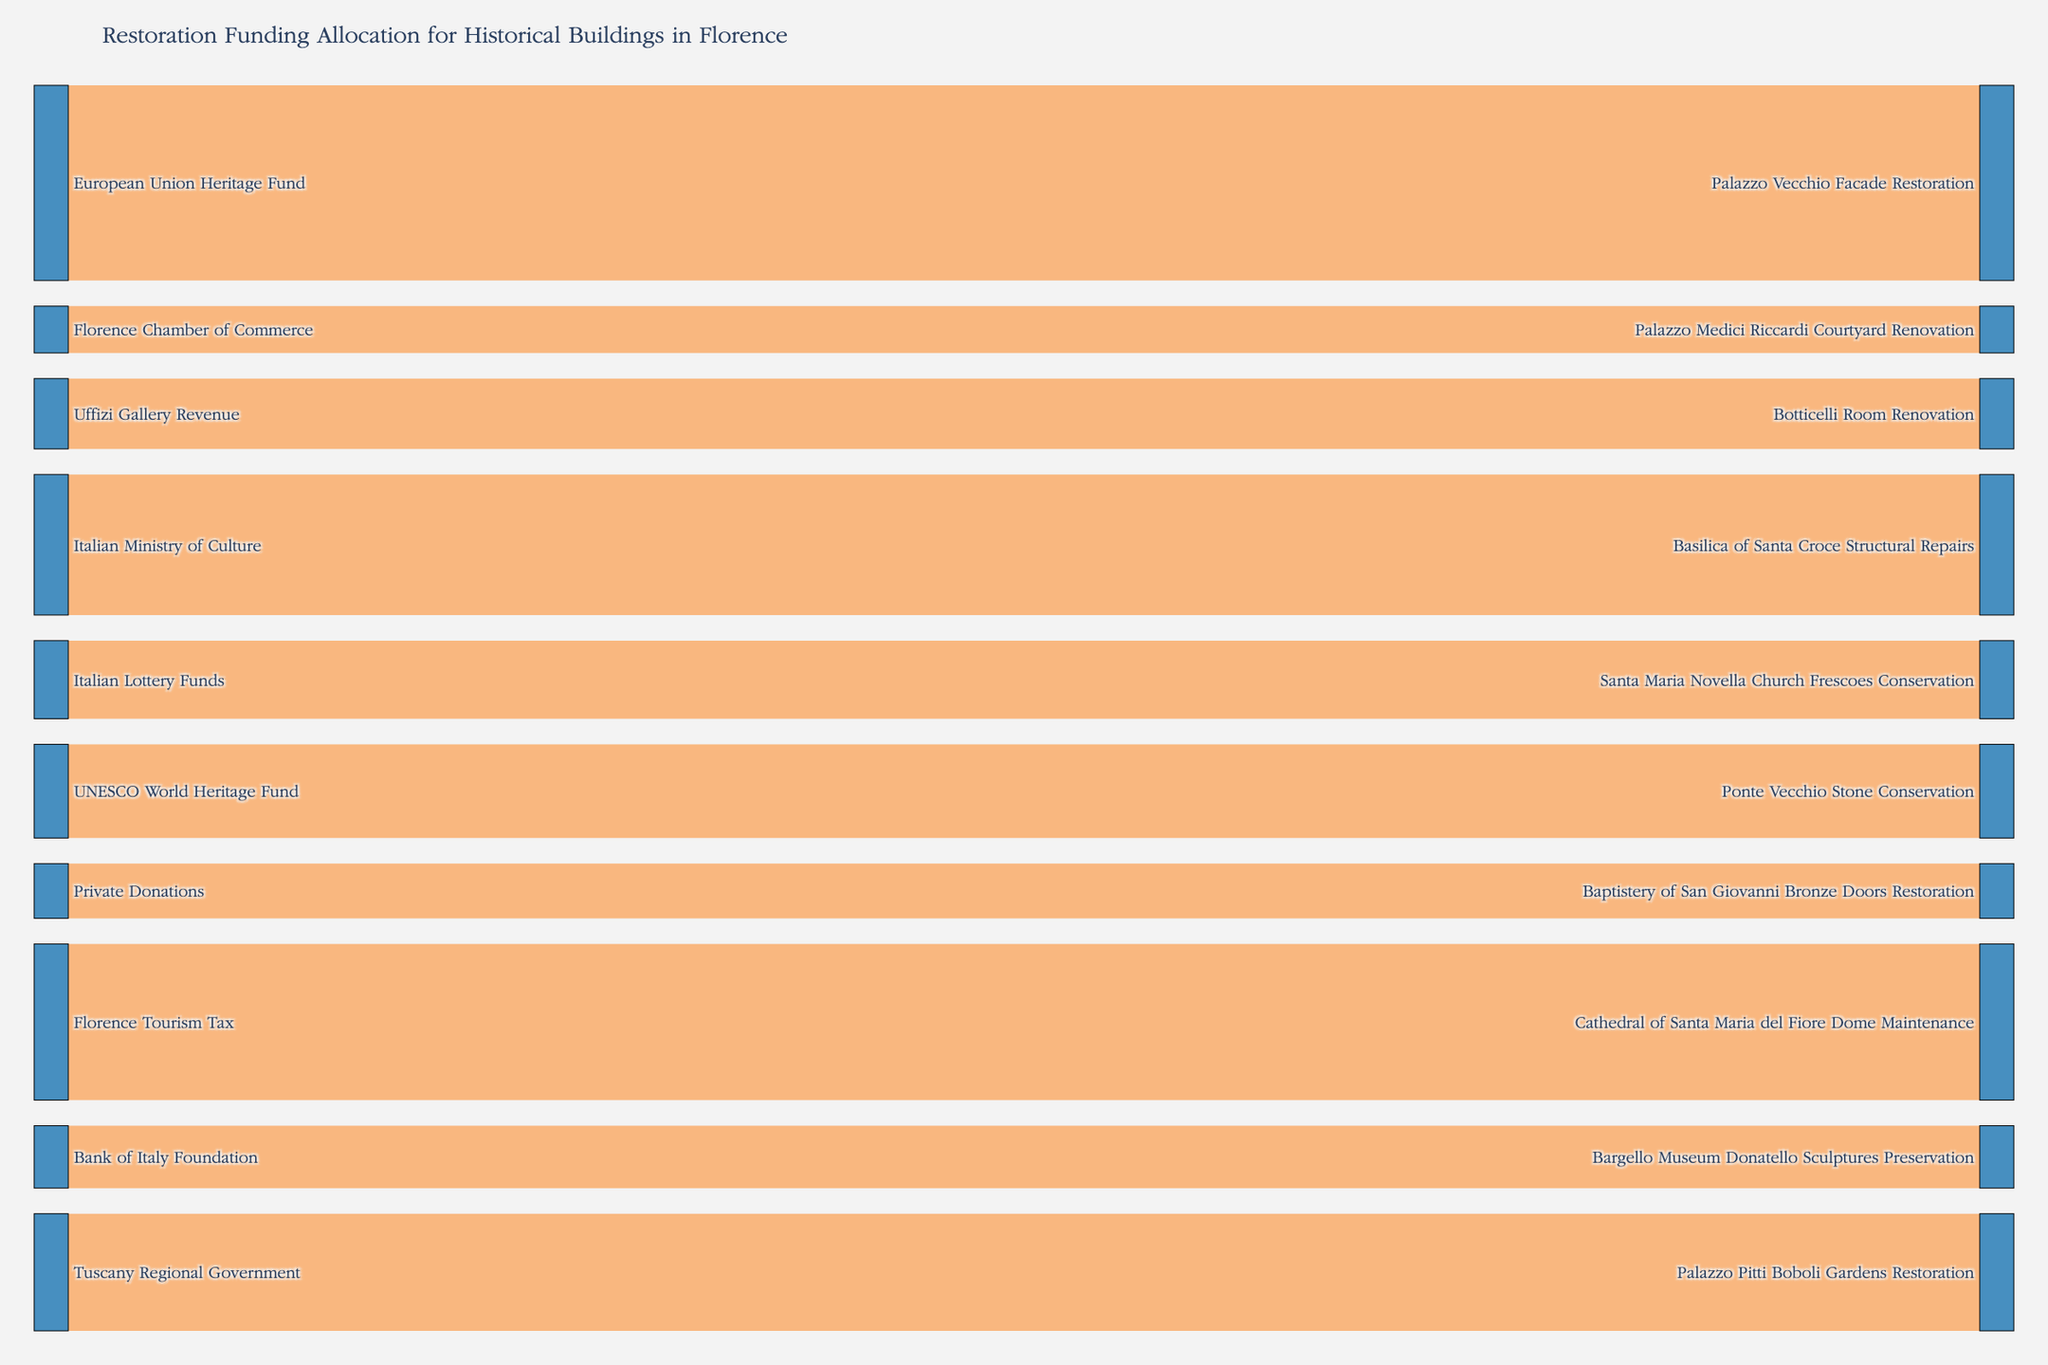What's the title of the figure? The title can be identified at the top of the Sankey diagram. It summarizes the primary focus of the visualization.
Answer: "Restoration Funding Allocation for Historical Buildings in Florence" How much funding was allocated to the Palazzo Vecchio Facade Restoration? Locate the destination "Palazzo Vecchio Facade Restoration" and follow the width of the flow from its source. The width directly correlates with the value.
Answer: 2,500,000 Which source contributed the highest amount of funding and to which projects? Compare the width of the flows from each source. The widest flow represents the highest value. Descriptions by the source name help identify the allocation projects.
Answer: "European Union Heritage Fund" contributed the highest, to "Palazzo Vecchio Facade Restoration" with 2,500,000 What is the total funding allocated for the Cathedral of Santa Maria del Fiore Dome Maintenance? Locate the destination "Cathedral of Santa Maria del Fiore Dome Maintenance" and sum the associated value flows leading to it.
Answer: 2,000,000 Which project received funding from the Friends of Florence Foundation? Trace the flow starting from "Friends of Florence Foundation" and see what destination it points towards.
Answer: Baptistery of San Giovanni Bronze Doors Restoration Compare the contributions from public versus private sources. What do you observe? Public sources include governmental and international funds, while private sources involve donations and organizational revenues. Sum the values of each category. Public: 8,880,000 (sum of multiple public sources). Private: 1,500,000 (sum of private donations and gallery revenue).
Answer: Public sources provide significantly more funding compared to private sources How many projects are funded by UNESCO World Heritage Fund and what are the allocated amounts? Identify the flows originating from "UNESCO World Heritage Fund" and note each destination and its value.
Answer: One project, 1,200,000 allocated to "Ponte Vecchio Stone Conservation." Which project received the least funding? Compare the values at the destination points; the flow with the smallest width represents the smallest funding.
Answer: "Palazzo Medici Riccardi Courtyard Renovation" with 600,000 What is the average amount of funding per project? Sum up the total funding (13,300,000) and divide by the number of projects (10). Total 13,300,000 / 10 projects = 1,330,000.
Answer: 1,330,000 Identify the projects funded by regional government sources and their cumulative total. Locate sources like "Tuscany Regional Government" and "Florence Chamber of Commerce" and sum their contributions. Tuscany Regional Government: 1,500,000 for one project and Florence Chamber of Commerce: 600,000 for another.
Answer: 2,100,000 